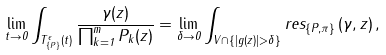Convert formula to latex. <formula><loc_0><loc_0><loc_500><loc_500>\lim _ { t \to 0 } \int _ { T ^ { \epsilon } _ { \left \{ { P } \right \} } ( t ) } \frac { \gamma ( z ) } { \prod _ { k = 1 } ^ { m } P _ { k } ( z ) } = \lim _ { \delta \to 0 } \int _ { V \cap \{ | g ( z ) | > \delta \} } r e s _ { \{ { P } , \pi \} } \left ( \gamma , z \right ) ,</formula> 